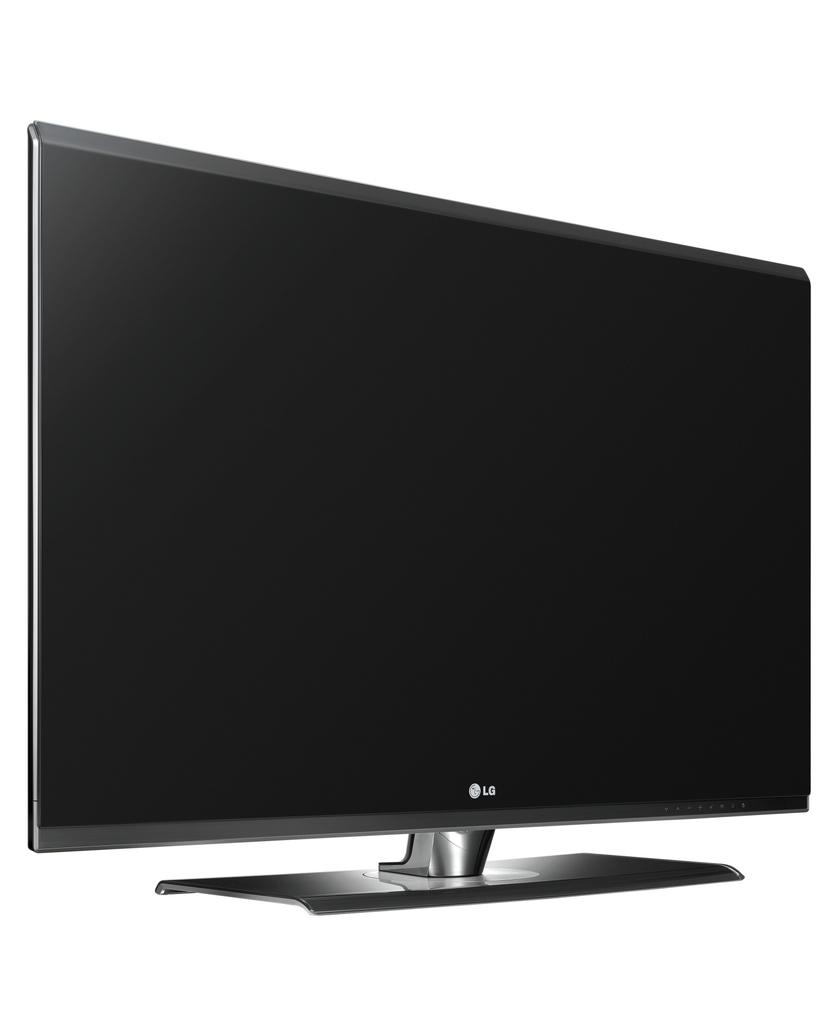<image>
Present a compact description of the photo's key features. A white screen with a LG computer monitor that is turned off 